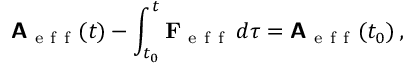Convert formula to latex. <formula><loc_0><loc_0><loc_500><loc_500>A _ { e f f } ( t ) - \int _ { t _ { 0 } } ^ { t } F _ { e f f } \, d \tau = A _ { e f f } ( t _ { 0 } ) \, ,</formula> 